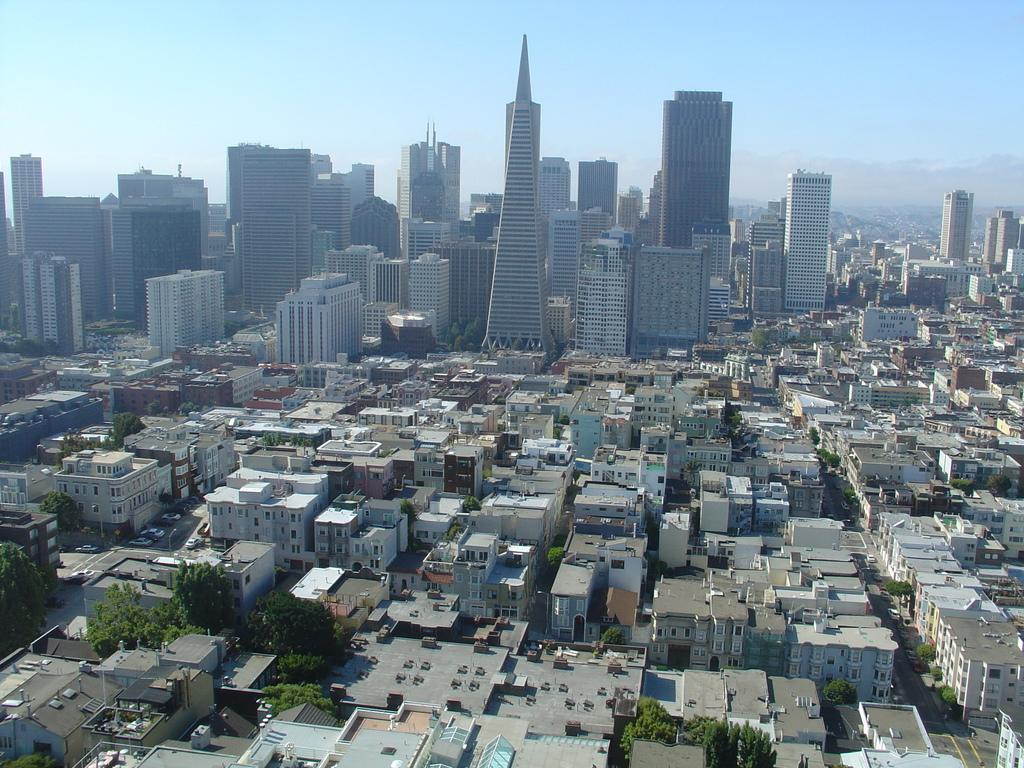What type of structures can be seen in the image? There are buildings in the image. What other natural elements are present in the image? There are trees in the image. Are there any man-made objects visible besides the buildings? Yes, there are vehicles in the image. What can be seen in the background of the image? The sky is visible in the background of the image. What is the condition of the sky in the image? Clouds are present in the sky. What type of lead pipe can be seen connecting the buildings in the image? There is no lead pipe visible in the image; it only features buildings, trees, vehicles, and a sky with clouds. 